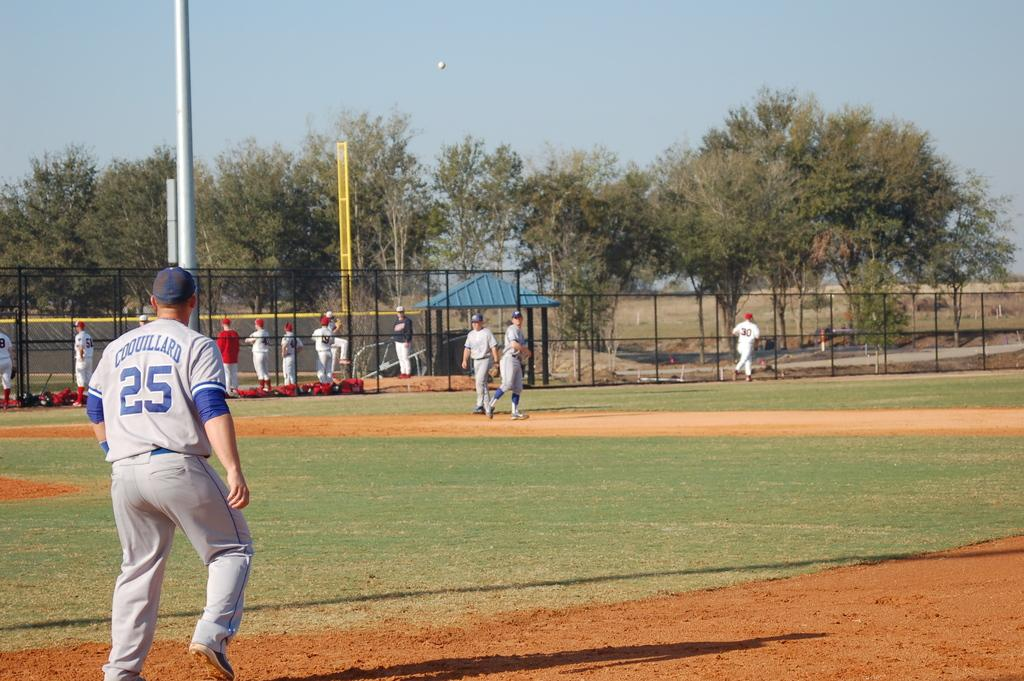<image>
Describe the image concisely. the number 25 that is on a jersey 